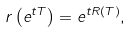<formula> <loc_0><loc_0><loc_500><loc_500>r \left ( e ^ { t T } \right ) = e ^ { t R ( T ) } ,</formula> 